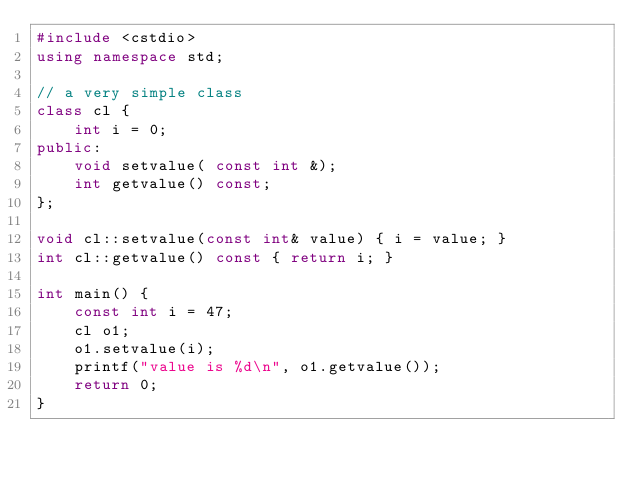<code> <loc_0><loc_0><loc_500><loc_500><_C++_>#include <cstdio>
using namespace std;

// a very simple class
class cl {
    int i = 0;
public:
    void setvalue( const int &);
    int getvalue() const;
};

void cl::setvalue(const int& value) { i = value; }
int cl::getvalue() const { return i; }

int main() {
    const int i = 47;
    cl o1;
    o1.setvalue(i);
    printf("value is %d\n", o1.getvalue());
    return 0;
}
</code> 